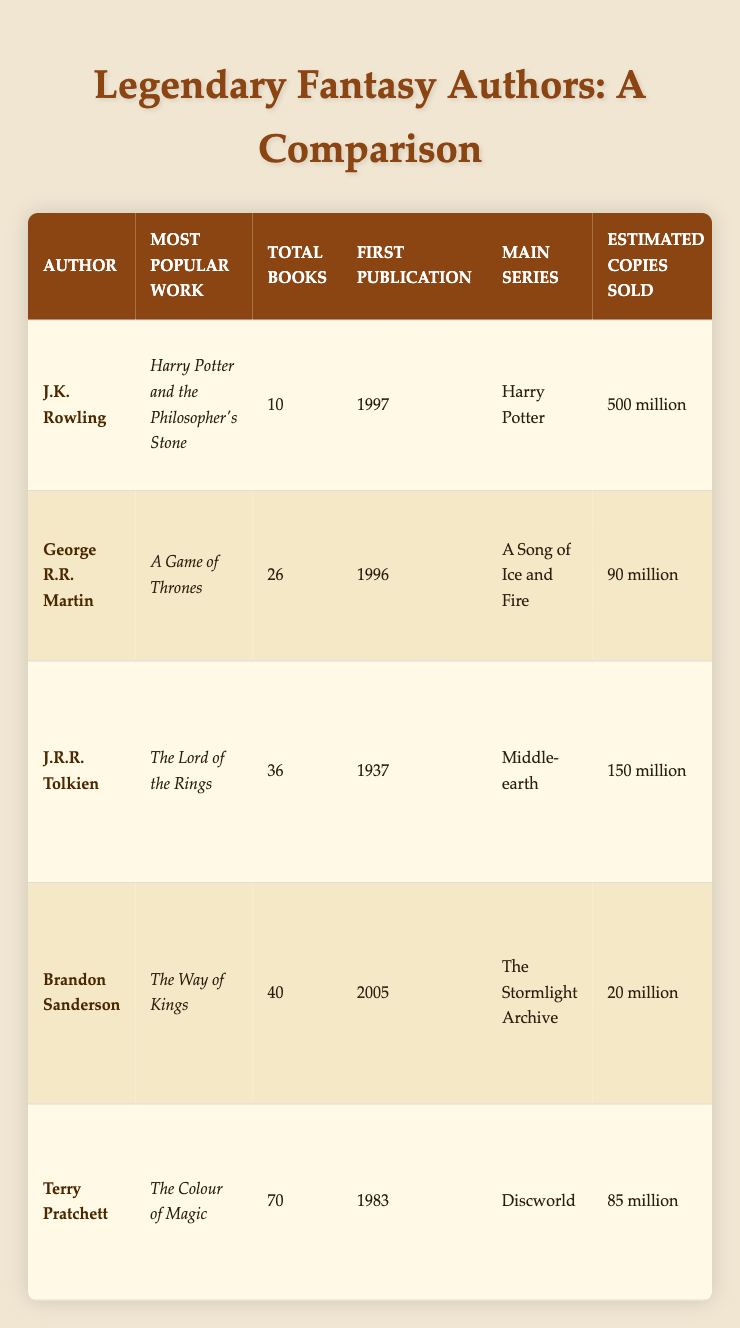What is the most popular work of J.K. Rowling? According to the table, J.K. Rowling's most popular work is "Harry Potter and the Philosopher's Stone." This information is found directly in the column corresponding to her name.
Answer: Harry Potter and the Philosopher's Stone Which author has the highest estimated copies sold? By reviewing the estimated copies sold for each author in the table, J.K. Rowling has 500 million copies sold. This is higher than the other authors listed.
Answer: J.K. Rowling How many total books has Terry Pratchett published? The table indicates that Terry Pratchett has published a total of 70 books, which can be directly read from the corresponding column.
Answer: 70 What is the difference in the number of books published between Brandon Sanderson and George R.R. Martin? Brandon Sanderson has published 40 books and George R.R. Martin has published 26 books. The difference is calculated as 40 - 26 = 14.
Answer: 14 Does J.R.R. Tolkien have any major awards listed? The table confirms that J.R.R. Tolkien has major awards. Specifically, he has received the International Fantasy Award and the Prometheus Hall of Fame Award. Thus, the answer is yes.
Answer: Yes Which author first published their works in 1996? Looking at the year of first publication for each author in the table, George R.R. Martin is the author who published his first work in 1996.
Answer: George R.R. Martin What adaptations are associated with The Colour of Magic? The adaptations listed for Terry Pratchett’s "The Colour of Magic" in the table include TV series, Movies, and Stage plays. Referring to the adaptations column confirms this information.
Answer: TV series, Movies, Stage plays If we average the estimated copies sold of all authors, what is the result? The estimated copies sold are: J.K. Rowling (500 million), George R.R. Martin (90 million), J.R.R. Tolkien (150 million), Brandon Sanderson (20 million), Terry Pratchett (85 million). Adding them gives 500 + 90 + 150 + 20 + 85 = 845 million. Dividing this by 5 gives an average of 169 million.
Answer: 169 million Which author has the least number of estimated copies sold? By examining the estimated copies sold column, Brandon Sanderson has the least with 20 million copies sold, less than each of the other authors.
Answer: Brandon Sanderson 